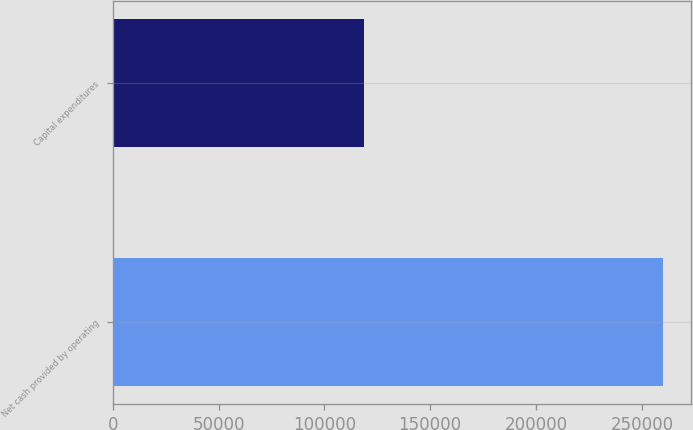Convert chart to OTSL. <chart><loc_0><loc_0><loc_500><loc_500><bar_chart><fcel>Net cash provided by operating<fcel>Capital expenditures<nl><fcel>260039<fcel>118912<nl></chart> 